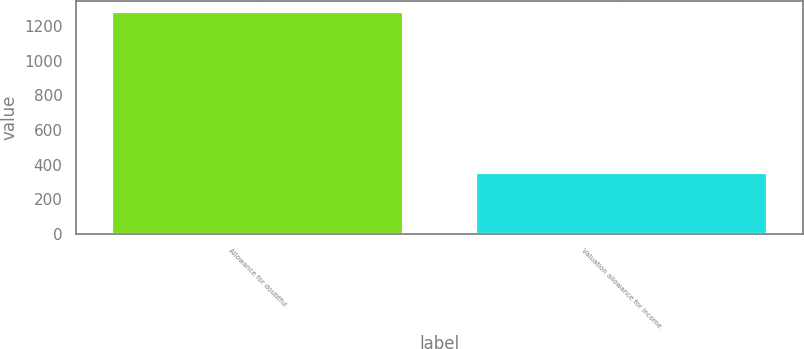<chart> <loc_0><loc_0><loc_500><loc_500><bar_chart><fcel>Allowance for doubtful<fcel>Valuation allowance for income<nl><fcel>1278<fcel>352<nl></chart> 